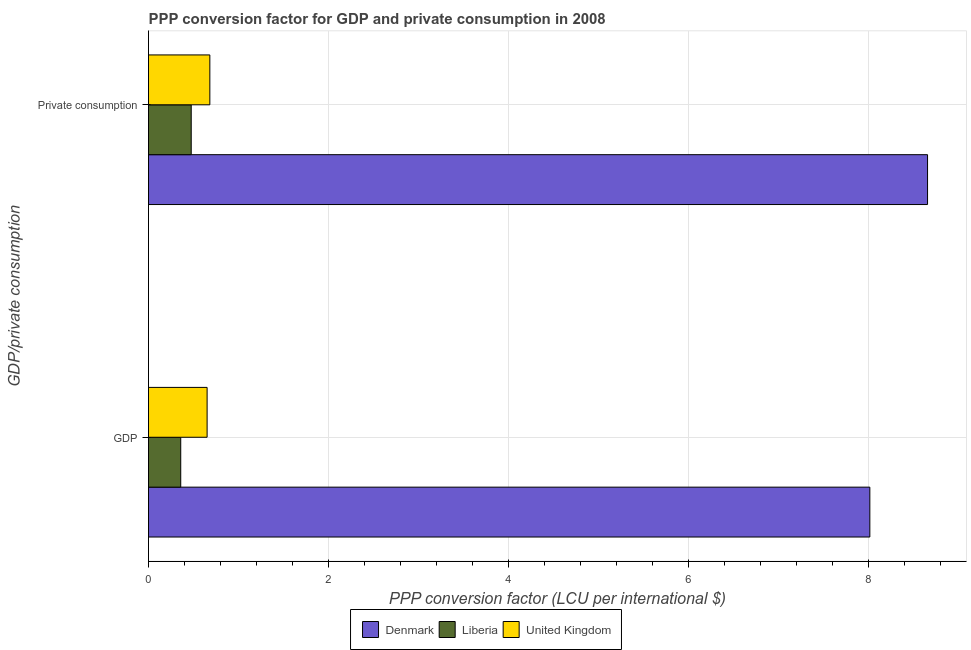How many different coloured bars are there?
Your answer should be very brief. 3. Are the number of bars on each tick of the Y-axis equal?
Offer a terse response. Yes. How many bars are there on the 1st tick from the top?
Provide a succinct answer. 3. What is the label of the 2nd group of bars from the top?
Give a very brief answer. GDP. What is the ppp conversion factor for gdp in Liberia?
Give a very brief answer. 0.36. Across all countries, what is the maximum ppp conversion factor for private consumption?
Keep it short and to the point. 8.65. Across all countries, what is the minimum ppp conversion factor for gdp?
Offer a terse response. 0.36. In which country was the ppp conversion factor for private consumption maximum?
Give a very brief answer. Denmark. In which country was the ppp conversion factor for gdp minimum?
Make the answer very short. Liberia. What is the total ppp conversion factor for private consumption in the graph?
Keep it short and to the point. 9.81. What is the difference between the ppp conversion factor for gdp in Liberia and that in Denmark?
Make the answer very short. -7.65. What is the difference between the ppp conversion factor for private consumption in Denmark and the ppp conversion factor for gdp in United Kingdom?
Offer a very short reply. 8. What is the average ppp conversion factor for gdp per country?
Your answer should be very brief. 3.01. What is the difference between the ppp conversion factor for private consumption and ppp conversion factor for gdp in Denmark?
Keep it short and to the point. 0.64. What is the ratio of the ppp conversion factor for gdp in Denmark to that in United Kingdom?
Offer a very short reply. 12.31. Is the ppp conversion factor for private consumption in United Kingdom less than that in Liberia?
Keep it short and to the point. No. What does the 3rd bar from the top in GDP represents?
Offer a terse response. Denmark. What does the 1st bar from the bottom in  Private consumption represents?
Your answer should be compact. Denmark. How many bars are there?
Give a very brief answer. 6. Does the graph contain grids?
Your answer should be compact. Yes. How many legend labels are there?
Provide a short and direct response. 3. What is the title of the graph?
Provide a succinct answer. PPP conversion factor for GDP and private consumption in 2008. What is the label or title of the X-axis?
Provide a short and direct response. PPP conversion factor (LCU per international $). What is the label or title of the Y-axis?
Your response must be concise. GDP/private consumption. What is the PPP conversion factor (LCU per international $) in Denmark in GDP?
Give a very brief answer. 8.01. What is the PPP conversion factor (LCU per international $) of Liberia in GDP?
Offer a very short reply. 0.36. What is the PPP conversion factor (LCU per international $) of United Kingdom in GDP?
Your answer should be compact. 0.65. What is the PPP conversion factor (LCU per international $) in Denmark in  Private consumption?
Offer a terse response. 8.65. What is the PPP conversion factor (LCU per international $) of Liberia in  Private consumption?
Ensure brevity in your answer.  0.47. What is the PPP conversion factor (LCU per international $) in United Kingdom in  Private consumption?
Make the answer very short. 0.68. Across all GDP/private consumption, what is the maximum PPP conversion factor (LCU per international $) of Denmark?
Provide a short and direct response. 8.65. Across all GDP/private consumption, what is the maximum PPP conversion factor (LCU per international $) of Liberia?
Give a very brief answer. 0.47. Across all GDP/private consumption, what is the maximum PPP conversion factor (LCU per international $) in United Kingdom?
Make the answer very short. 0.68. Across all GDP/private consumption, what is the minimum PPP conversion factor (LCU per international $) in Denmark?
Your answer should be compact. 8.01. Across all GDP/private consumption, what is the minimum PPP conversion factor (LCU per international $) of Liberia?
Your answer should be very brief. 0.36. Across all GDP/private consumption, what is the minimum PPP conversion factor (LCU per international $) in United Kingdom?
Make the answer very short. 0.65. What is the total PPP conversion factor (LCU per international $) of Denmark in the graph?
Ensure brevity in your answer.  16.67. What is the total PPP conversion factor (LCU per international $) of Liberia in the graph?
Your answer should be compact. 0.83. What is the total PPP conversion factor (LCU per international $) in United Kingdom in the graph?
Provide a short and direct response. 1.33. What is the difference between the PPP conversion factor (LCU per international $) in Denmark in GDP and that in  Private consumption?
Provide a succinct answer. -0.64. What is the difference between the PPP conversion factor (LCU per international $) in Liberia in GDP and that in  Private consumption?
Provide a succinct answer. -0.12. What is the difference between the PPP conversion factor (LCU per international $) of United Kingdom in GDP and that in  Private consumption?
Keep it short and to the point. -0.03. What is the difference between the PPP conversion factor (LCU per international $) of Denmark in GDP and the PPP conversion factor (LCU per international $) of Liberia in  Private consumption?
Your response must be concise. 7.54. What is the difference between the PPP conversion factor (LCU per international $) of Denmark in GDP and the PPP conversion factor (LCU per international $) of United Kingdom in  Private consumption?
Make the answer very short. 7.33. What is the difference between the PPP conversion factor (LCU per international $) in Liberia in GDP and the PPP conversion factor (LCU per international $) in United Kingdom in  Private consumption?
Your response must be concise. -0.32. What is the average PPP conversion factor (LCU per international $) of Denmark per GDP/private consumption?
Your answer should be compact. 8.33. What is the average PPP conversion factor (LCU per international $) of Liberia per GDP/private consumption?
Give a very brief answer. 0.42. What is the average PPP conversion factor (LCU per international $) in United Kingdom per GDP/private consumption?
Your answer should be compact. 0.67. What is the difference between the PPP conversion factor (LCU per international $) of Denmark and PPP conversion factor (LCU per international $) of Liberia in GDP?
Provide a succinct answer. 7.65. What is the difference between the PPP conversion factor (LCU per international $) of Denmark and PPP conversion factor (LCU per international $) of United Kingdom in GDP?
Make the answer very short. 7.36. What is the difference between the PPP conversion factor (LCU per international $) in Liberia and PPP conversion factor (LCU per international $) in United Kingdom in GDP?
Give a very brief answer. -0.29. What is the difference between the PPP conversion factor (LCU per international $) in Denmark and PPP conversion factor (LCU per international $) in Liberia in  Private consumption?
Provide a succinct answer. 8.18. What is the difference between the PPP conversion factor (LCU per international $) of Denmark and PPP conversion factor (LCU per international $) of United Kingdom in  Private consumption?
Your answer should be very brief. 7.97. What is the difference between the PPP conversion factor (LCU per international $) in Liberia and PPP conversion factor (LCU per international $) in United Kingdom in  Private consumption?
Your response must be concise. -0.21. What is the ratio of the PPP conversion factor (LCU per international $) of Denmark in GDP to that in  Private consumption?
Make the answer very short. 0.93. What is the ratio of the PPP conversion factor (LCU per international $) of Liberia in GDP to that in  Private consumption?
Keep it short and to the point. 0.75. What is the ratio of the PPP conversion factor (LCU per international $) in United Kingdom in GDP to that in  Private consumption?
Provide a succinct answer. 0.96. What is the difference between the highest and the second highest PPP conversion factor (LCU per international $) in Denmark?
Keep it short and to the point. 0.64. What is the difference between the highest and the second highest PPP conversion factor (LCU per international $) of Liberia?
Offer a very short reply. 0.12. What is the difference between the highest and the second highest PPP conversion factor (LCU per international $) of United Kingdom?
Ensure brevity in your answer.  0.03. What is the difference between the highest and the lowest PPP conversion factor (LCU per international $) in Denmark?
Your response must be concise. 0.64. What is the difference between the highest and the lowest PPP conversion factor (LCU per international $) of Liberia?
Offer a very short reply. 0.12. What is the difference between the highest and the lowest PPP conversion factor (LCU per international $) in United Kingdom?
Your response must be concise. 0.03. 